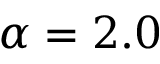<formula> <loc_0><loc_0><loc_500><loc_500>\alpha = 2 . 0</formula> 